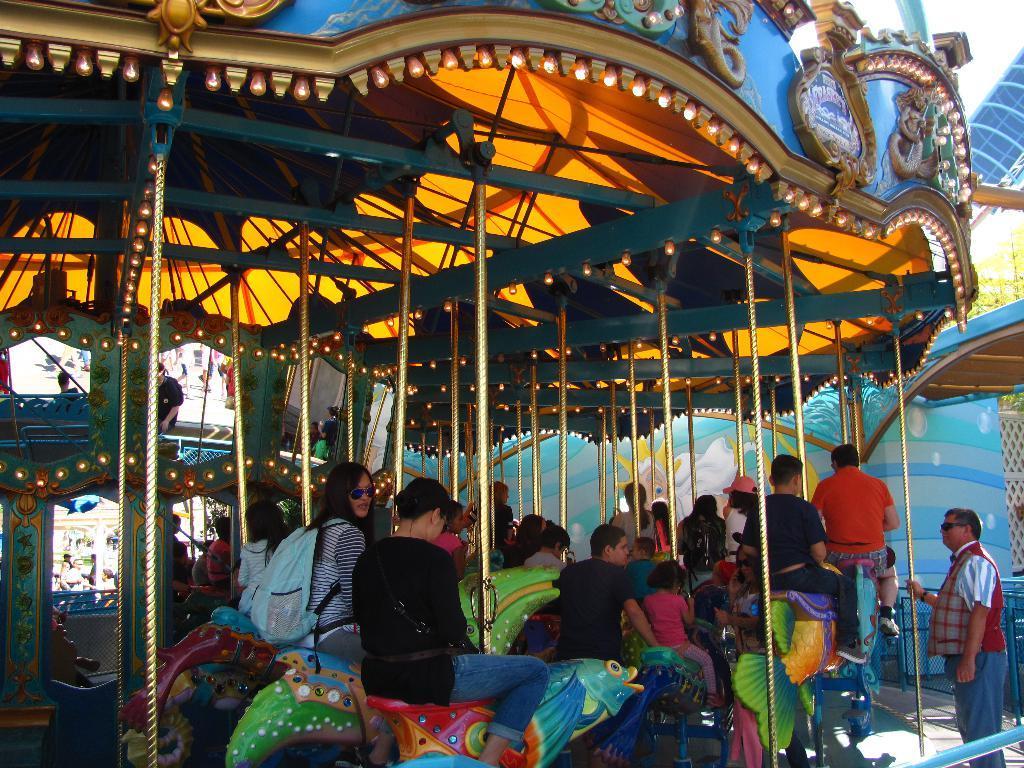Describe this image in one or two sentences. In this image on the right there is a man, he wears a shirt, trouser, he is standing. In the middle there is a man, he wears a black t shirt. On the left there is a woman, she wears a t shirt, trouser and bag and there is a woman. In the background there are many people, lights, toys, sky. 